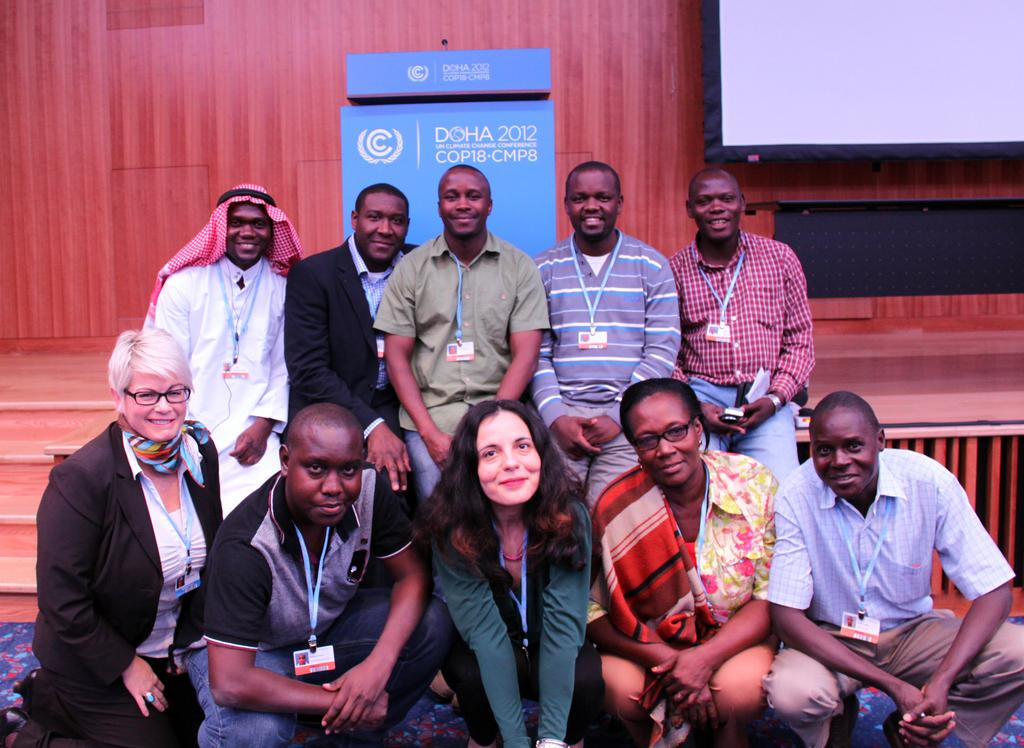How many people are in the image? There are persons visible in the image. Where are the persons located in relation to the stage? The persons are in front of a stage. What is attached to the wooden fence behind the persons? There is a screen attached to a wooden fence behind the persons. What type of stone can be seen in the image? There is no stone present in the image. What is the visibility like in the image? The visibility is clear in the image, as there is no mention of mist or any other obscuring elements. 